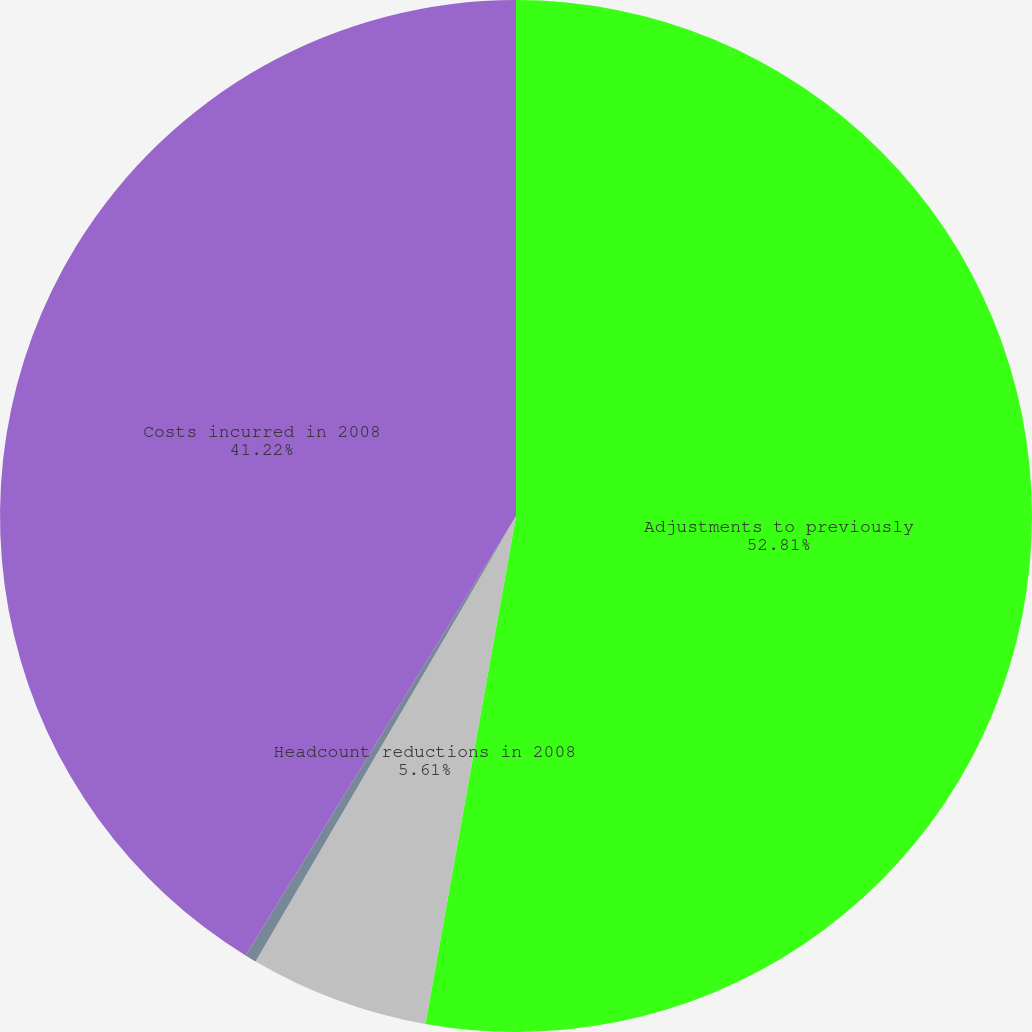<chart> <loc_0><loc_0><loc_500><loc_500><pie_chart><fcel>Adjustments to previously<fcel>Headcount reductions in 2008<fcel>Balance December 31 2008<fcel>Costs incurred in 2008<nl><fcel>52.81%<fcel>5.61%<fcel>0.36%<fcel>41.22%<nl></chart> 